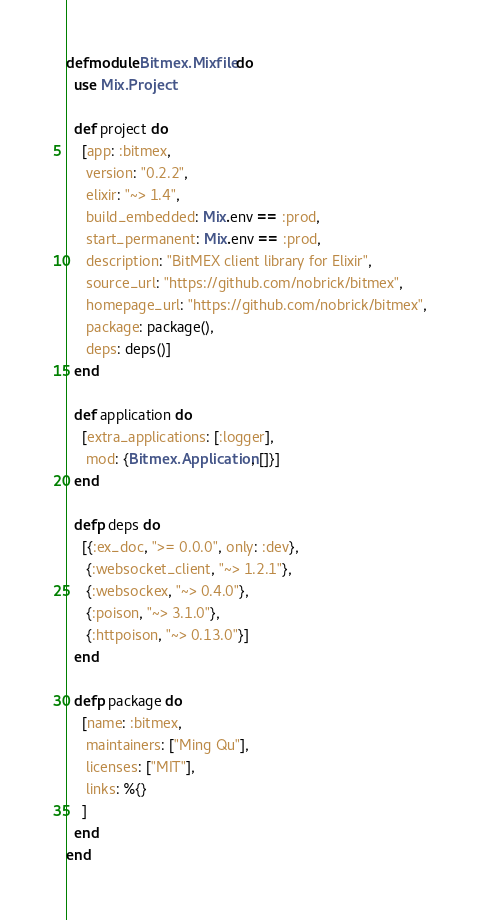<code> <loc_0><loc_0><loc_500><loc_500><_Elixir_>defmodule Bitmex.Mixfile do
  use Mix.Project

  def project do
    [app: :bitmex,
     version: "0.2.2",
     elixir: "~> 1.4",
     build_embedded: Mix.env == :prod,
     start_permanent: Mix.env == :prod,
     description: "BitMEX client library for Elixir",
     source_url: "https://github.com/nobrick/bitmex",
     homepage_url: "https://github.com/nobrick/bitmex",
     package: package(),
     deps: deps()]
  end

  def application do
    [extra_applications: [:logger],
     mod: {Bitmex.Application, []}]
  end

  defp deps do
    [{:ex_doc, ">= 0.0.0", only: :dev},
     {:websocket_client, "~> 1.2.1"},
     {:websockex, "~> 0.4.0"},
     {:poison, "~> 3.1.0"},
     {:httpoison, "~> 0.13.0"}]
  end

  defp package do
    [name: :bitmex,
     maintainers: ["Ming Qu"],
     licenses: ["MIT"],
     links: %{}
    ]
  end
end
</code> 